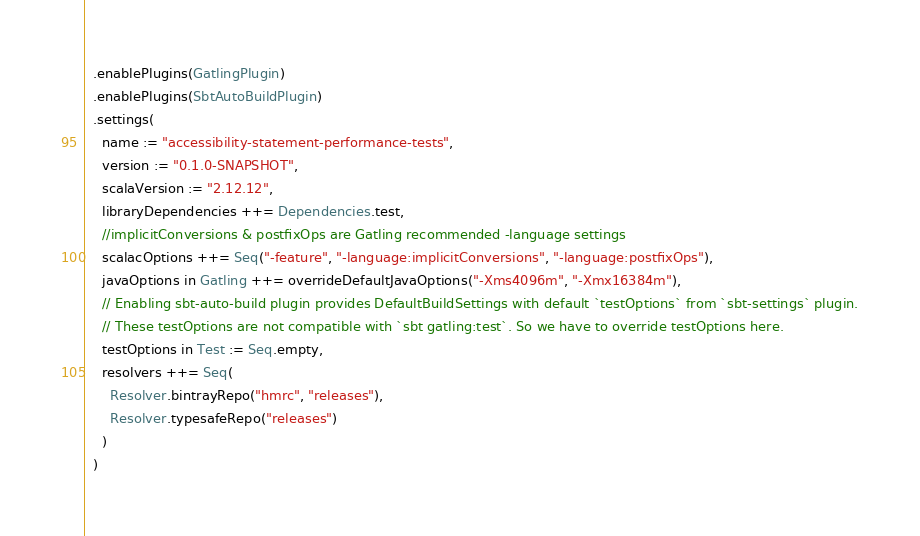<code> <loc_0><loc_0><loc_500><loc_500><_Scala_>  .enablePlugins(GatlingPlugin)
  .enablePlugins(SbtAutoBuildPlugin)
  .settings(
    name := "accessibility-statement-performance-tests",
    version := "0.1.0-SNAPSHOT",
    scalaVersion := "2.12.12",
    libraryDependencies ++= Dependencies.test,
    //implicitConversions & postfixOps are Gatling recommended -language settings
    scalacOptions ++= Seq("-feature", "-language:implicitConversions", "-language:postfixOps"),
    javaOptions in Gatling ++= overrideDefaultJavaOptions("-Xms4096m", "-Xmx16384m"),
    // Enabling sbt-auto-build plugin provides DefaultBuildSettings with default `testOptions` from `sbt-settings` plugin.
    // These testOptions are not compatible with `sbt gatling:test`. So we have to override testOptions here.
    testOptions in Test := Seq.empty,
    resolvers ++= Seq(
      Resolver.bintrayRepo("hmrc", "releases"),
      Resolver.typesafeRepo("releases")
    )
  )
</code> 